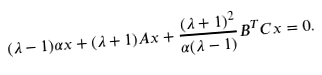Convert formula to latex. <formula><loc_0><loc_0><loc_500><loc_500>( \lambda - 1 ) \alpha x + ( \lambda + 1 ) A x + \frac { ( \lambda + 1 ) ^ { 2 } } { \alpha ( \lambda - 1 ) } B ^ { T } C x = 0 .</formula> 